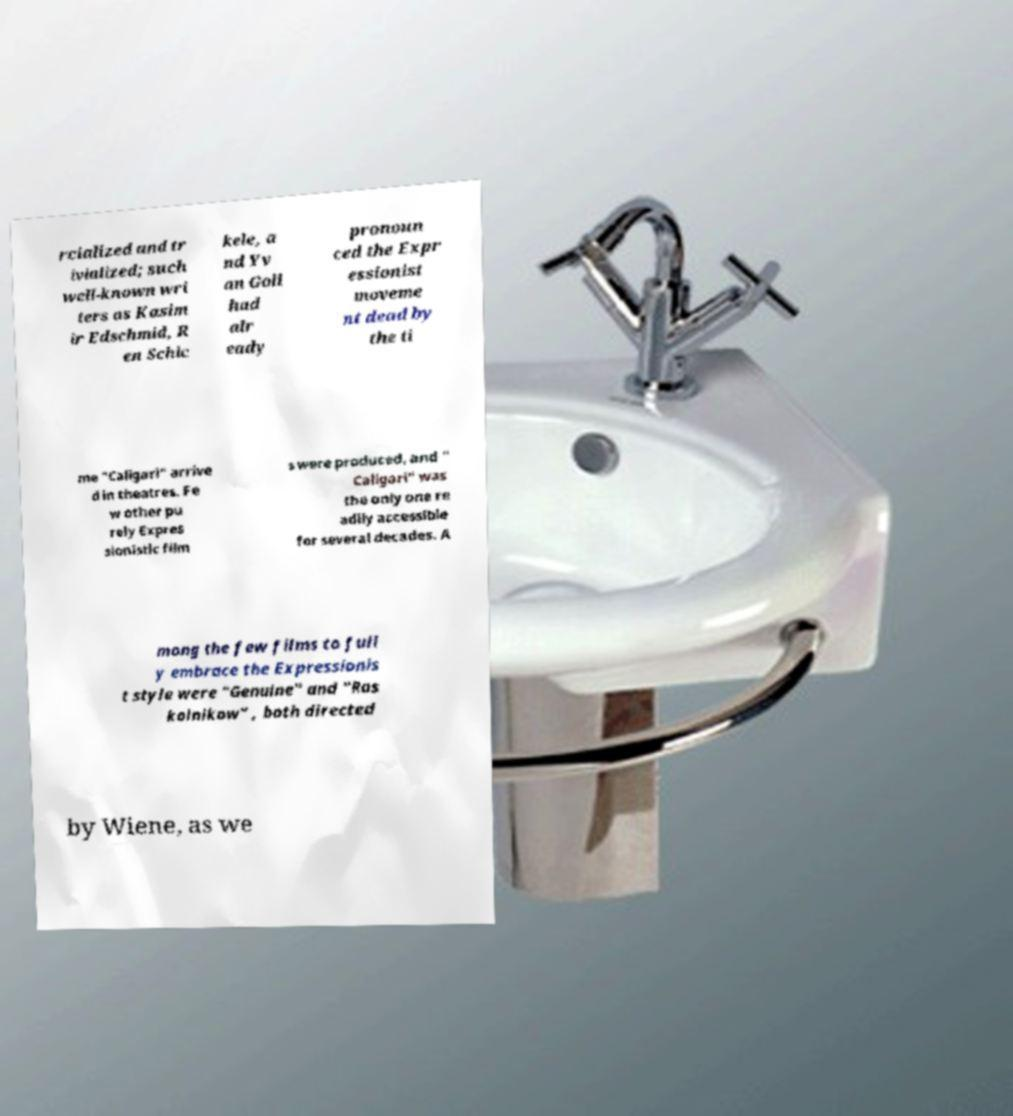Can you accurately transcribe the text from the provided image for me? rcialized and tr ivialized; such well-known wri ters as Kasim ir Edschmid, R en Schic kele, a nd Yv an Goll had alr eady pronoun ced the Expr essionist moveme nt dead by the ti me "Caligari" arrive d in theatres. Fe w other pu rely Expres sionistic film s were produced, and " Caligari" was the only one re adily accessible for several decades. A mong the few films to full y embrace the Expressionis t style were "Genuine" and "Ras kolnikow" , both directed by Wiene, as we 